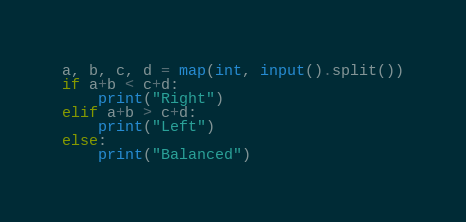<code> <loc_0><loc_0><loc_500><loc_500><_Python_>a, b, c, d = map(int, input().split())
if a+b < c+d:
    print("Right")
elif a+b > c+d:
    print("Left")
else:
    print("Balanced")</code> 